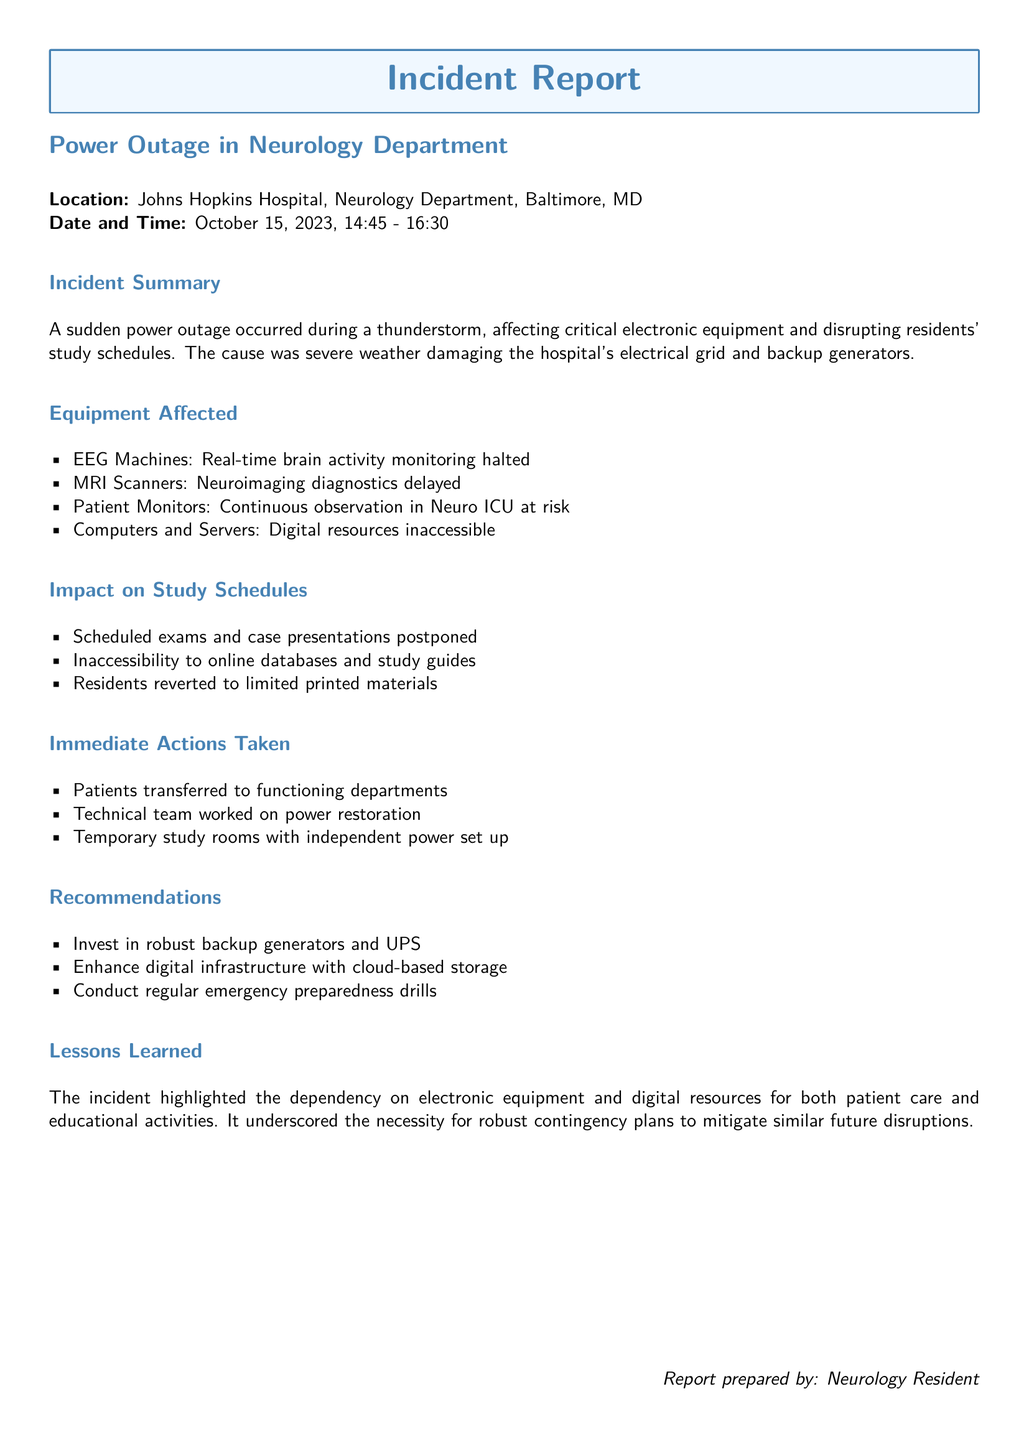What is the location of the incident? The location of the incident is specified in the incident report as Johns Hopkins Hospital, Neurology Department, Baltimore, MD.
Answer: Johns Hopkins Hospital, Neurology Department, Baltimore, MD When did the power outage occur? The date and time of the incident are detailed, stating that the power outage occurred on October 15, 2023, from 14:45 to 16:30.
Answer: October 15, 2023, 14:45 - 16:30 What caused the power outage? The report mentions that the cause of the power outage was severe weather damaging the hospital's electrical grid and backup generators.
Answer: Severe weather Which electronic equipment was impacted? The report lists several pieces of equipment that were affected, including EEG machines, MRI scanners, patient monitors, and computers.
Answer: EEG Machines, MRI Scanners, Patient Monitors, Computers What immediate action was taken regarding patients? The report indicates that patients were transferred to functioning departments as an immediate action taken during the outage.
Answer: Patients transferred to functioning departments How were residents affected in terms of study materials? The report highlights that residents faced inaccessibility to online databases and study guides due to the power outage.
Answer: Inaccessibility to online databases and study guides What recommendation was made regarding backup power? The incident report includes a recommendation to invest in robust backup generators and UPS as part of the solutions proposed.
Answer: Invest in robust backup generators and UPS What did the incident reveal about equipment dependency? The report states that the incident highlighted the dependency on electronic equipment and digital resources for both patient care and educational activities.
Answer: Dependency on electronic equipment and digital resources What should be conducted regularly according to the recommendations? The recommendations section suggests conducting regular emergency preparedness drills.
Answer: Regular emergency preparedness drills 